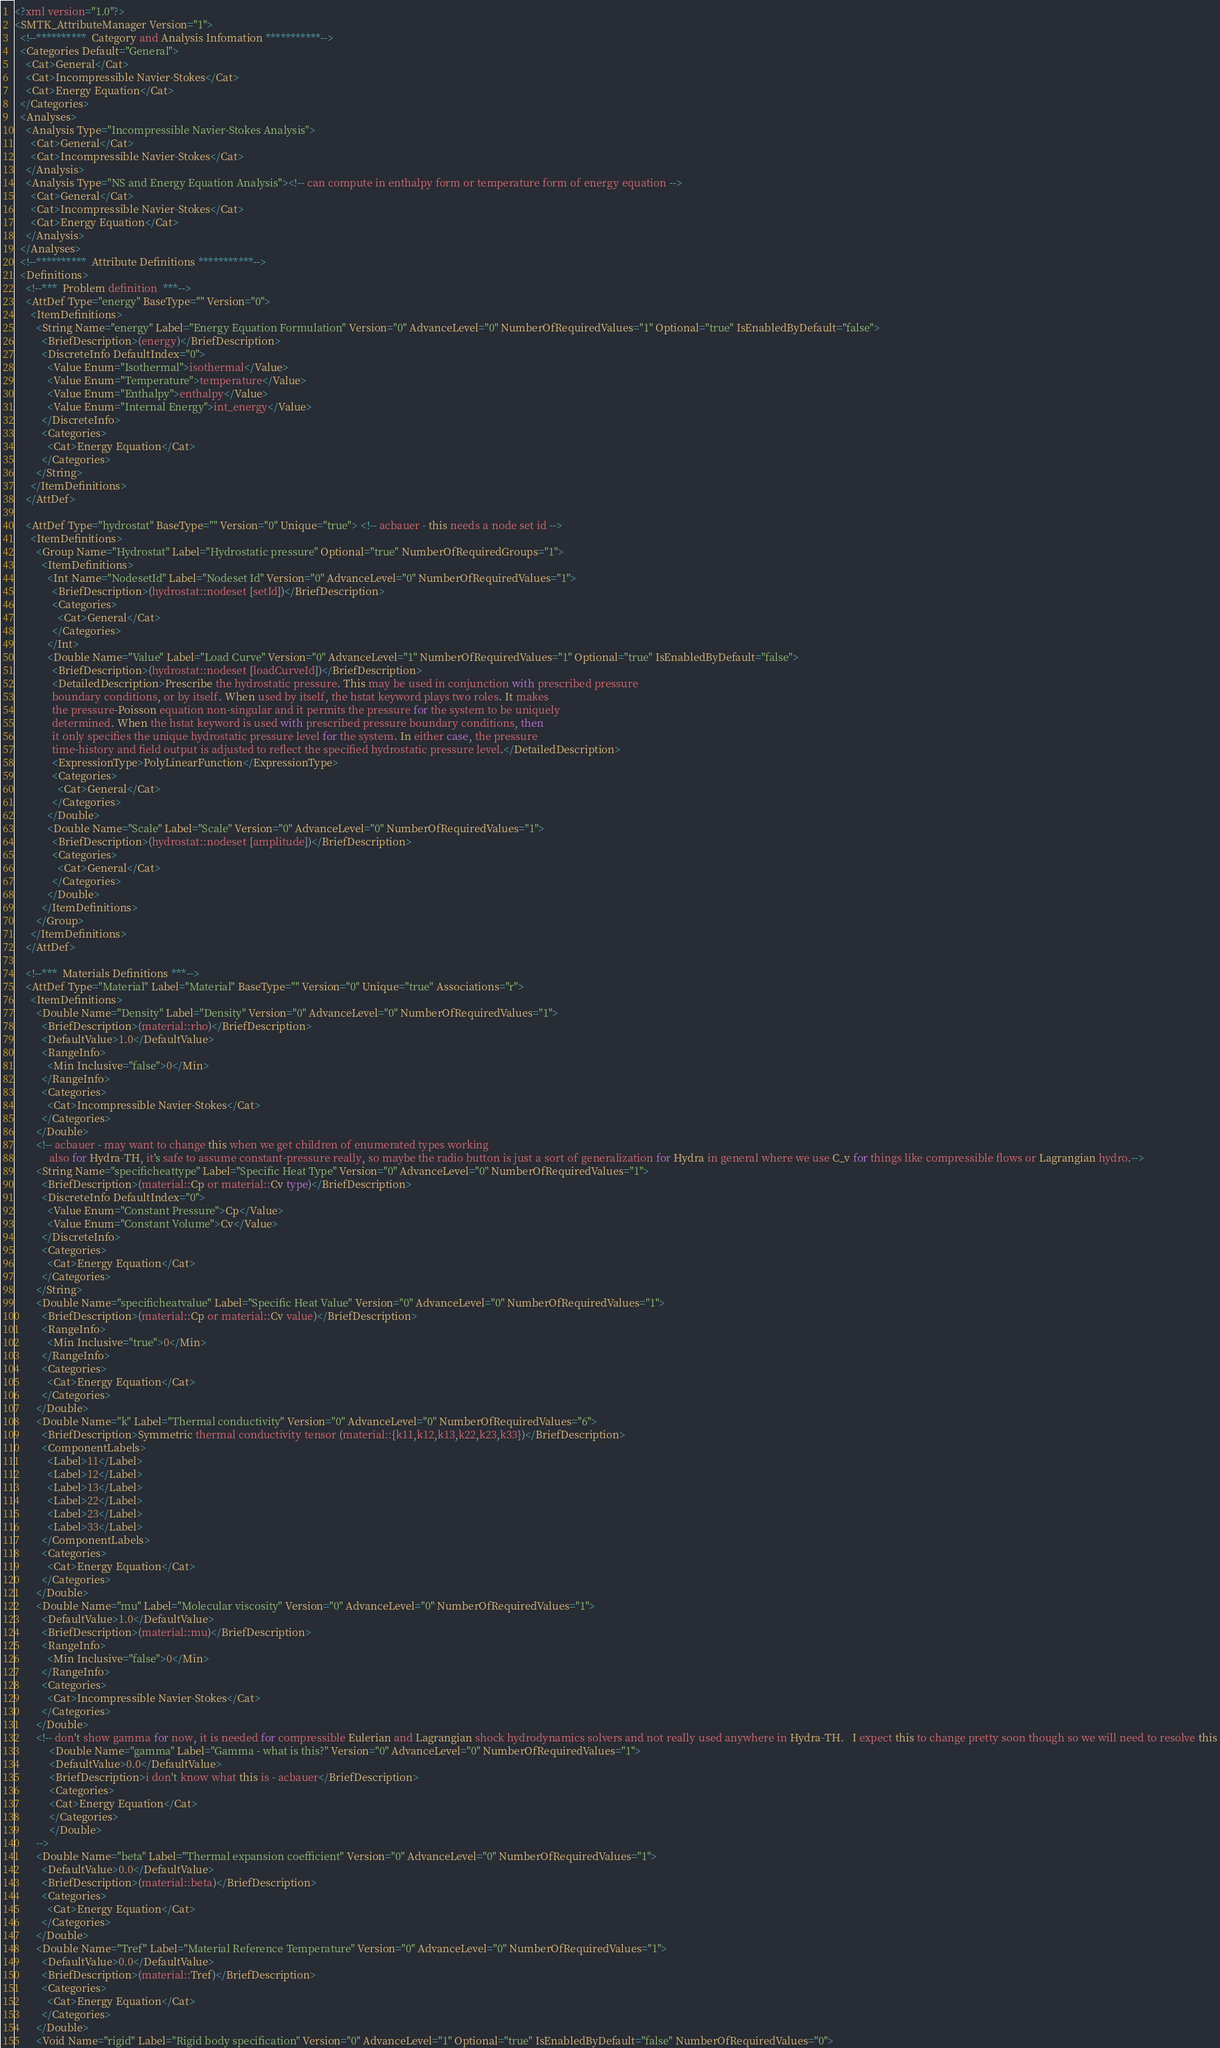<code> <loc_0><loc_0><loc_500><loc_500><_Scala_><?xml version="1.0"?>
<SMTK_AttributeManager Version="1">
  <!--**********  Category and Analysis Infomation ***********-->
  <Categories Default="General">
    <Cat>General</Cat>
    <Cat>Incompressible Navier-Stokes</Cat>
    <Cat>Energy Equation</Cat>
  </Categories>
  <Analyses>
    <Analysis Type="Incompressible Navier-Stokes Analysis">
      <Cat>General</Cat>
      <Cat>Incompressible Navier-Stokes</Cat>
    </Analysis>
    <Analysis Type="NS and Energy Equation Analysis"><!-- can compute in enthalpy form or temperature form of energy equation -->
      <Cat>General</Cat>
      <Cat>Incompressible Navier-Stokes</Cat>
      <Cat>Energy Equation</Cat>
    </Analysis>
  </Analyses>
  <!--**********  Attribute Definitions ***********-->
  <Definitions>
    <!--***  Problem definition  ***-->
    <AttDef Type="energy" BaseType="" Version="0">
      <ItemDefinitions>
        <String Name="energy" Label="Energy Equation Formulation" Version="0" AdvanceLevel="0" NumberOfRequiredValues="1" Optional="true" IsEnabledByDefault="false">
          <BriefDescription>(energy)</BriefDescription>
          <DiscreteInfo DefaultIndex="0">
            <Value Enum="Isothermal">isothermal</Value>
            <Value Enum="Temperature">temperature</Value>
            <Value Enum="Enthalpy">enthalpy</Value>
            <Value Enum="Internal Energy">int_energy</Value>
          </DiscreteInfo>
          <Categories>
            <Cat>Energy Equation</Cat>
          </Categories>
        </String>
      </ItemDefinitions>
    </AttDef>

    <AttDef Type="hydrostat" BaseType="" Version="0" Unique="true"> <!-- acbauer - this needs a node set id -->
      <ItemDefinitions>
        <Group Name="Hydrostat" Label="Hydrostatic pressure" Optional="true" NumberOfRequiredGroups="1">
          <ItemDefinitions>
            <Int Name="NodesetId" Label="Nodeset Id" Version="0" AdvanceLevel="0" NumberOfRequiredValues="1">
              <BriefDescription>(hydrostat::nodeset [setId])</BriefDescription>
              <Categories>
                <Cat>General</Cat>
              </Categories>
            </Int>
            <Double Name="Value" Label="Load Curve" Version="0" AdvanceLevel="1" NumberOfRequiredValues="1" Optional="true" IsEnabledByDefault="false">
              <BriefDescription>(hydrostat::nodeset [loadCurveId])</BriefDescription>
              <DetailedDescription>Prescribe the hydrostatic pressure. This may be used in conjunction with prescribed pressure
              boundary conditions, or by itself. When used by itself, the hstat keyword plays two roles. It makes
              the pressure-Poisson equation non-singular and it permits the pressure for the system to be uniquely
              determined. When the hstat keyword is used with prescribed pressure boundary conditions, then
              it only specifies the unique hydrostatic pressure level for the system. In either case, the pressure
              time-history and field output is adjusted to reflect the specified hydrostatic pressure level.</DetailedDescription>
              <ExpressionType>PolyLinearFunction</ExpressionType>
              <Categories>
                <Cat>General</Cat>
              </Categories>
            </Double>
            <Double Name="Scale" Label="Scale" Version="0" AdvanceLevel="0" NumberOfRequiredValues="1">
              <BriefDescription>(hydrostat::nodeset [amplitude])</BriefDescription>
              <Categories>
                <Cat>General</Cat>
              </Categories>
            </Double>
          </ItemDefinitions>
        </Group>
      </ItemDefinitions>
    </AttDef>

    <!--***  Materials Definitions ***-->
    <AttDef Type="Material" Label="Material" BaseType="" Version="0" Unique="true" Associations="r">
      <ItemDefinitions>
        <Double Name="Density" Label="Density" Version="0" AdvanceLevel="0" NumberOfRequiredValues="1">
          <BriefDescription>(material::rho)</BriefDescription>
          <DefaultValue>1.0</DefaultValue>
          <RangeInfo>
            <Min Inclusive="false">0</Min>
          </RangeInfo>
          <Categories>
            <Cat>Incompressible Navier-Stokes</Cat>
          </Categories>
        </Double>
        <!-- acbauer - may want to change this when we get children of enumerated types working
             also for Hydra-TH, it's safe to assume constant-pressure really, so maybe the radio button is just a sort of generalization for Hydra in general where we use C_v for things like compressible flows or Lagrangian hydro.-->
        <String Name="specificheattype" Label="Specific Heat Type" Version="0" AdvanceLevel="0" NumberOfRequiredValues="1">
          <BriefDescription>(material::Cp or material::Cv type)</BriefDescription>
          <DiscreteInfo DefaultIndex="0">
            <Value Enum="Constant Pressure">Cp</Value>
            <Value Enum="Constant Volume">Cv</Value>
          </DiscreteInfo>
          <Categories>
            <Cat>Energy Equation</Cat>
          </Categories>
        </String>
        <Double Name="specificheatvalue" Label="Specific Heat Value" Version="0" AdvanceLevel="0" NumberOfRequiredValues="1">
          <BriefDescription>(material::Cp or material::Cv value)</BriefDescription>
          <RangeInfo>
            <Min Inclusive="true">0</Min>
          </RangeInfo>
          <Categories>
            <Cat>Energy Equation</Cat>
          </Categories>
        </Double>
        <Double Name="k" Label="Thermal conductivity" Version="0" AdvanceLevel="0" NumberOfRequiredValues="6">
          <BriefDescription>Symmetric thermal conductivity tensor (material::{k11,k12,k13,k22,k23,k33})</BriefDescription>
          <ComponentLabels>
            <Label>11</Label>
            <Label>12</Label>
            <Label>13</Label>
            <Label>22</Label>
            <Label>23</Label>
            <Label>33</Label>
          </ComponentLabels>
          <Categories>
            <Cat>Energy Equation</Cat>
          </Categories>
        </Double>
        <Double Name="mu" Label="Molecular viscosity" Version="0" AdvanceLevel="0" NumberOfRequiredValues="1">
          <DefaultValue>1.0</DefaultValue>
          <BriefDescription>(material::mu)</BriefDescription>
          <RangeInfo>
            <Min Inclusive="false">0</Min>
          </RangeInfo>
          <Categories>
            <Cat>Incompressible Navier-Stokes</Cat>
          </Categories>
        </Double>
        <!-- don't show gamma for now, it is needed for compressible Eulerian and Lagrangian shock hydrodynamics solvers and not really used anywhere in Hydra-TH.   I expect this to change pretty soon though so we will need to resolve this
             <Double Name="gamma" Label="Gamma - what is this?" Version="0" AdvanceLevel="0" NumberOfRequiredValues="1">
             <DefaultValue>0.0</DefaultValue>
             <BriefDescription>i don't know what this is - acbauer</BriefDescription>
             <Categories>
             <Cat>Energy Equation</Cat>
             </Categories>
             </Double>
        -->
        <Double Name="beta" Label="Thermal expansion coefficient" Version="0" AdvanceLevel="0" NumberOfRequiredValues="1">
          <DefaultValue>0.0</DefaultValue>
          <BriefDescription>(material::beta)</BriefDescription>
          <Categories>
            <Cat>Energy Equation</Cat>
          </Categories>
        </Double>
        <Double Name="Tref" Label="Material Reference Temperature" Version="0" AdvanceLevel="0" NumberOfRequiredValues="1">
          <DefaultValue>0.0</DefaultValue>
          <BriefDescription>(material::Tref)</BriefDescription>
          <Categories>
            <Cat>Energy Equation</Cat>
          </Categories>
        </Double>
        <Void Name="rigid" Label="Rigid body specification" Version="0" AdvanceLevel="1" Optional="true" IsEnabledByDefault="false" NumberOfRequiredValues="0"></code> 